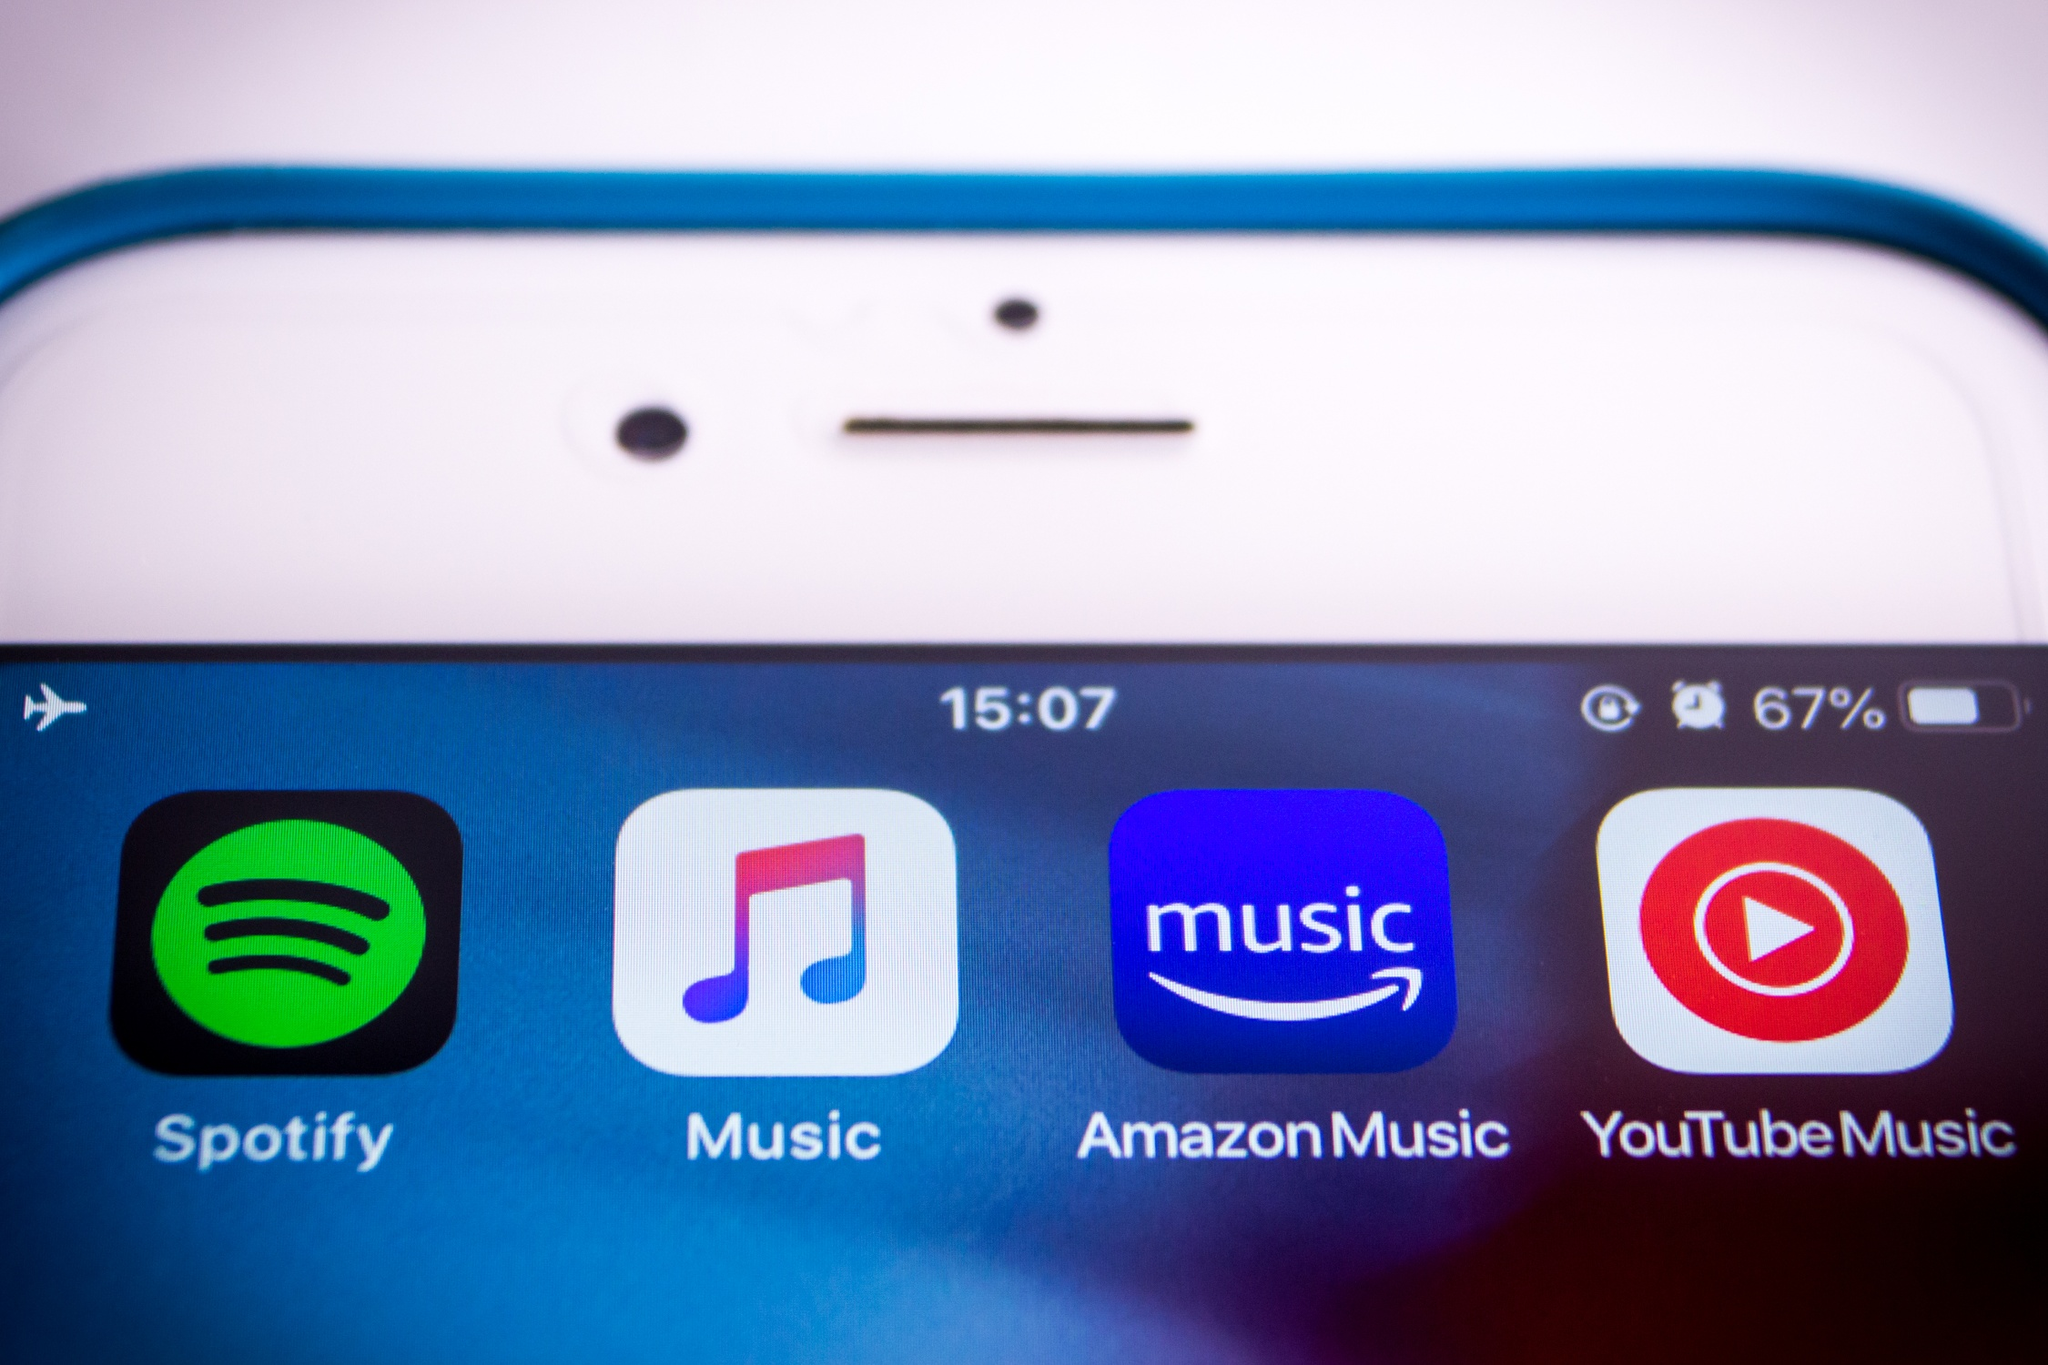Imagine if the phone screen showed apps not for streaming music, but for something entirely fantastical. What could it display? Let’s dive into a world of imagination! If the phone screen showcased apps for fantastical purposes, it might display icons for these magical applications:

- **Dragon Tamer:** An app to manage and care for your collection of dragons. Track their growth, plan their training sessions, and embark on epic quests together.

- **Potion Master:** A comprehensive potion-making guide. Recipes for potions to change the weather, enhance physical abilities, or transform into mythical creatures are just a tap away.

- **Time Traveler:** Plan and execute your journeys through time. Schedule trips, learn about historical events firsthand, and return untouched by the constraints of linear time.

- **Spell Binder:** Store and organize your spellbook. Learn new spells from ancient scrolls, practice casting, and join worldwide magical tournaments. What if one of these apps had a notification? What could it be? If one of these fantastical apps had a notification, it could be something intriguing like:

**Dragon Tamer:** *“Your baby dragon, Ember, is ready for its first flight! Guide it through the skies and discover hidden secrets!”*

**Potion Master:** *“New potion ingredients available! Collect the rare Phoenix Feather and Unicorn Hair for your next masterpiece.”*

**Time Traveler:** *“Event Alert: Witness the fall of the Berlin Wall firsthand! Departing in 10 minutes.”*

**Spell Binder:** *“New Spell Unlocked! ‘Invisibility Cloak’ – practice now to perfect your stealth skills.”* 